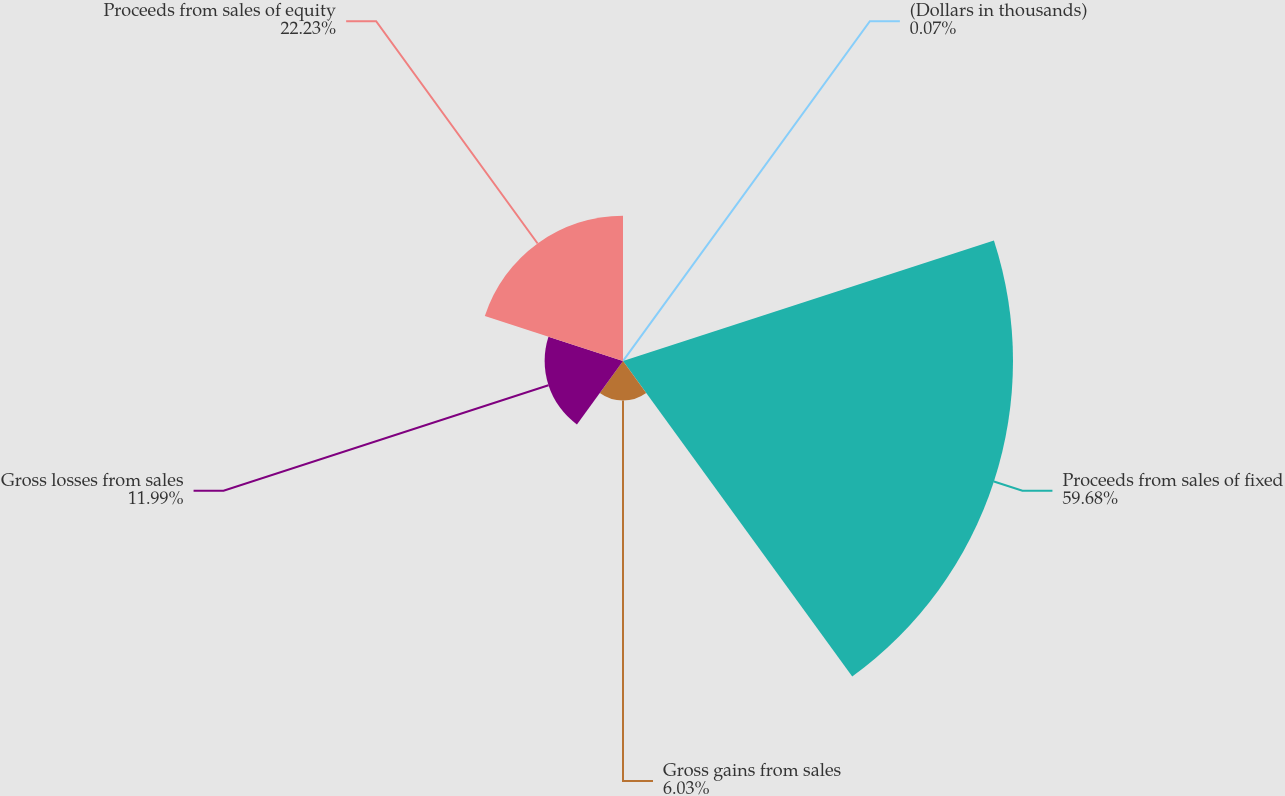Convert chart to OTSL. <chart><loc_0><loc_0><loc_500><loc_500><pie_chart><fcel>(Dollars in thousands)<fcel>Proceeds from sales of fixed<fcel>Gross gains from sales<fcel>Gross losses from sales<fcel>Proceeds from sales of equity<nl><fcel>0.07%<fcel>59.68%<fcel>6.03%<fcel>11.99%<fcel>22.23%<nl></chart> 